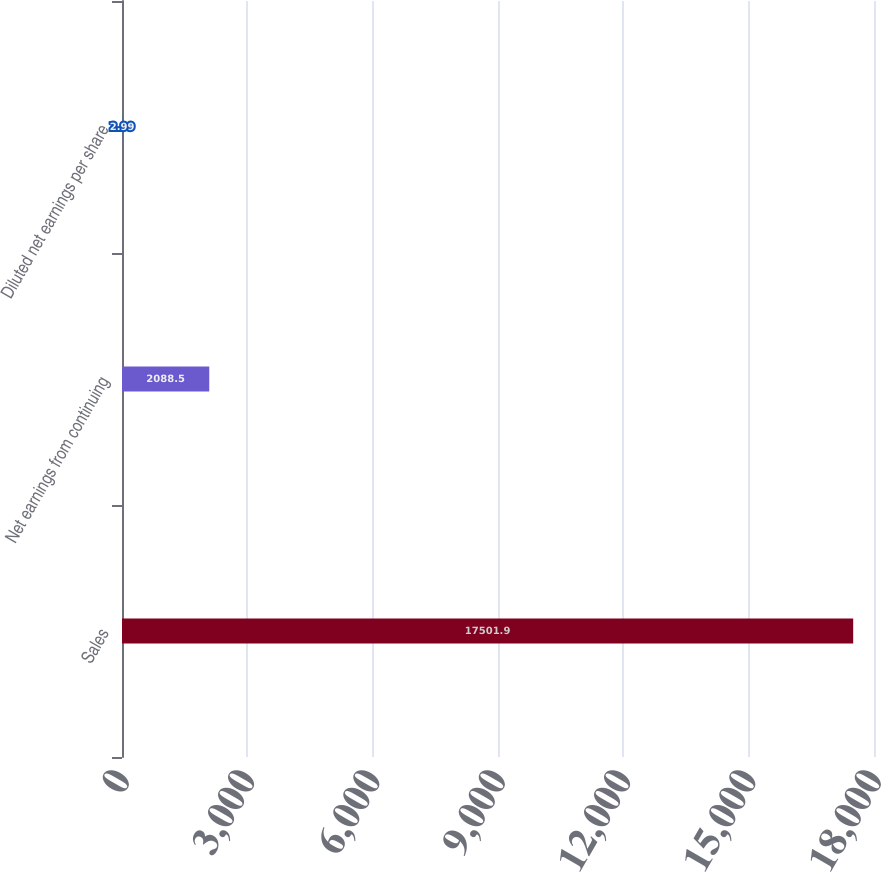<chart> <loc_0><loc_0><loc_500><loc_500><bar_chart><fcel>Sales<fcel>Net earnings from continuing<fcel>Diluted net earnings per share<nl><fcel>17501.9<fcel>2088.5<fcel>2.99<nl></chart> 